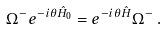Convert formula to latex. <formula><loc_0><loc_0><loc_500><loc_500>\Omega ^ { - } e ^ { - i \theta \hat { H } _ { 0 } } = e ^ { - i \theta \hat { H } } \Omega ^ { - } \, .</formula> 